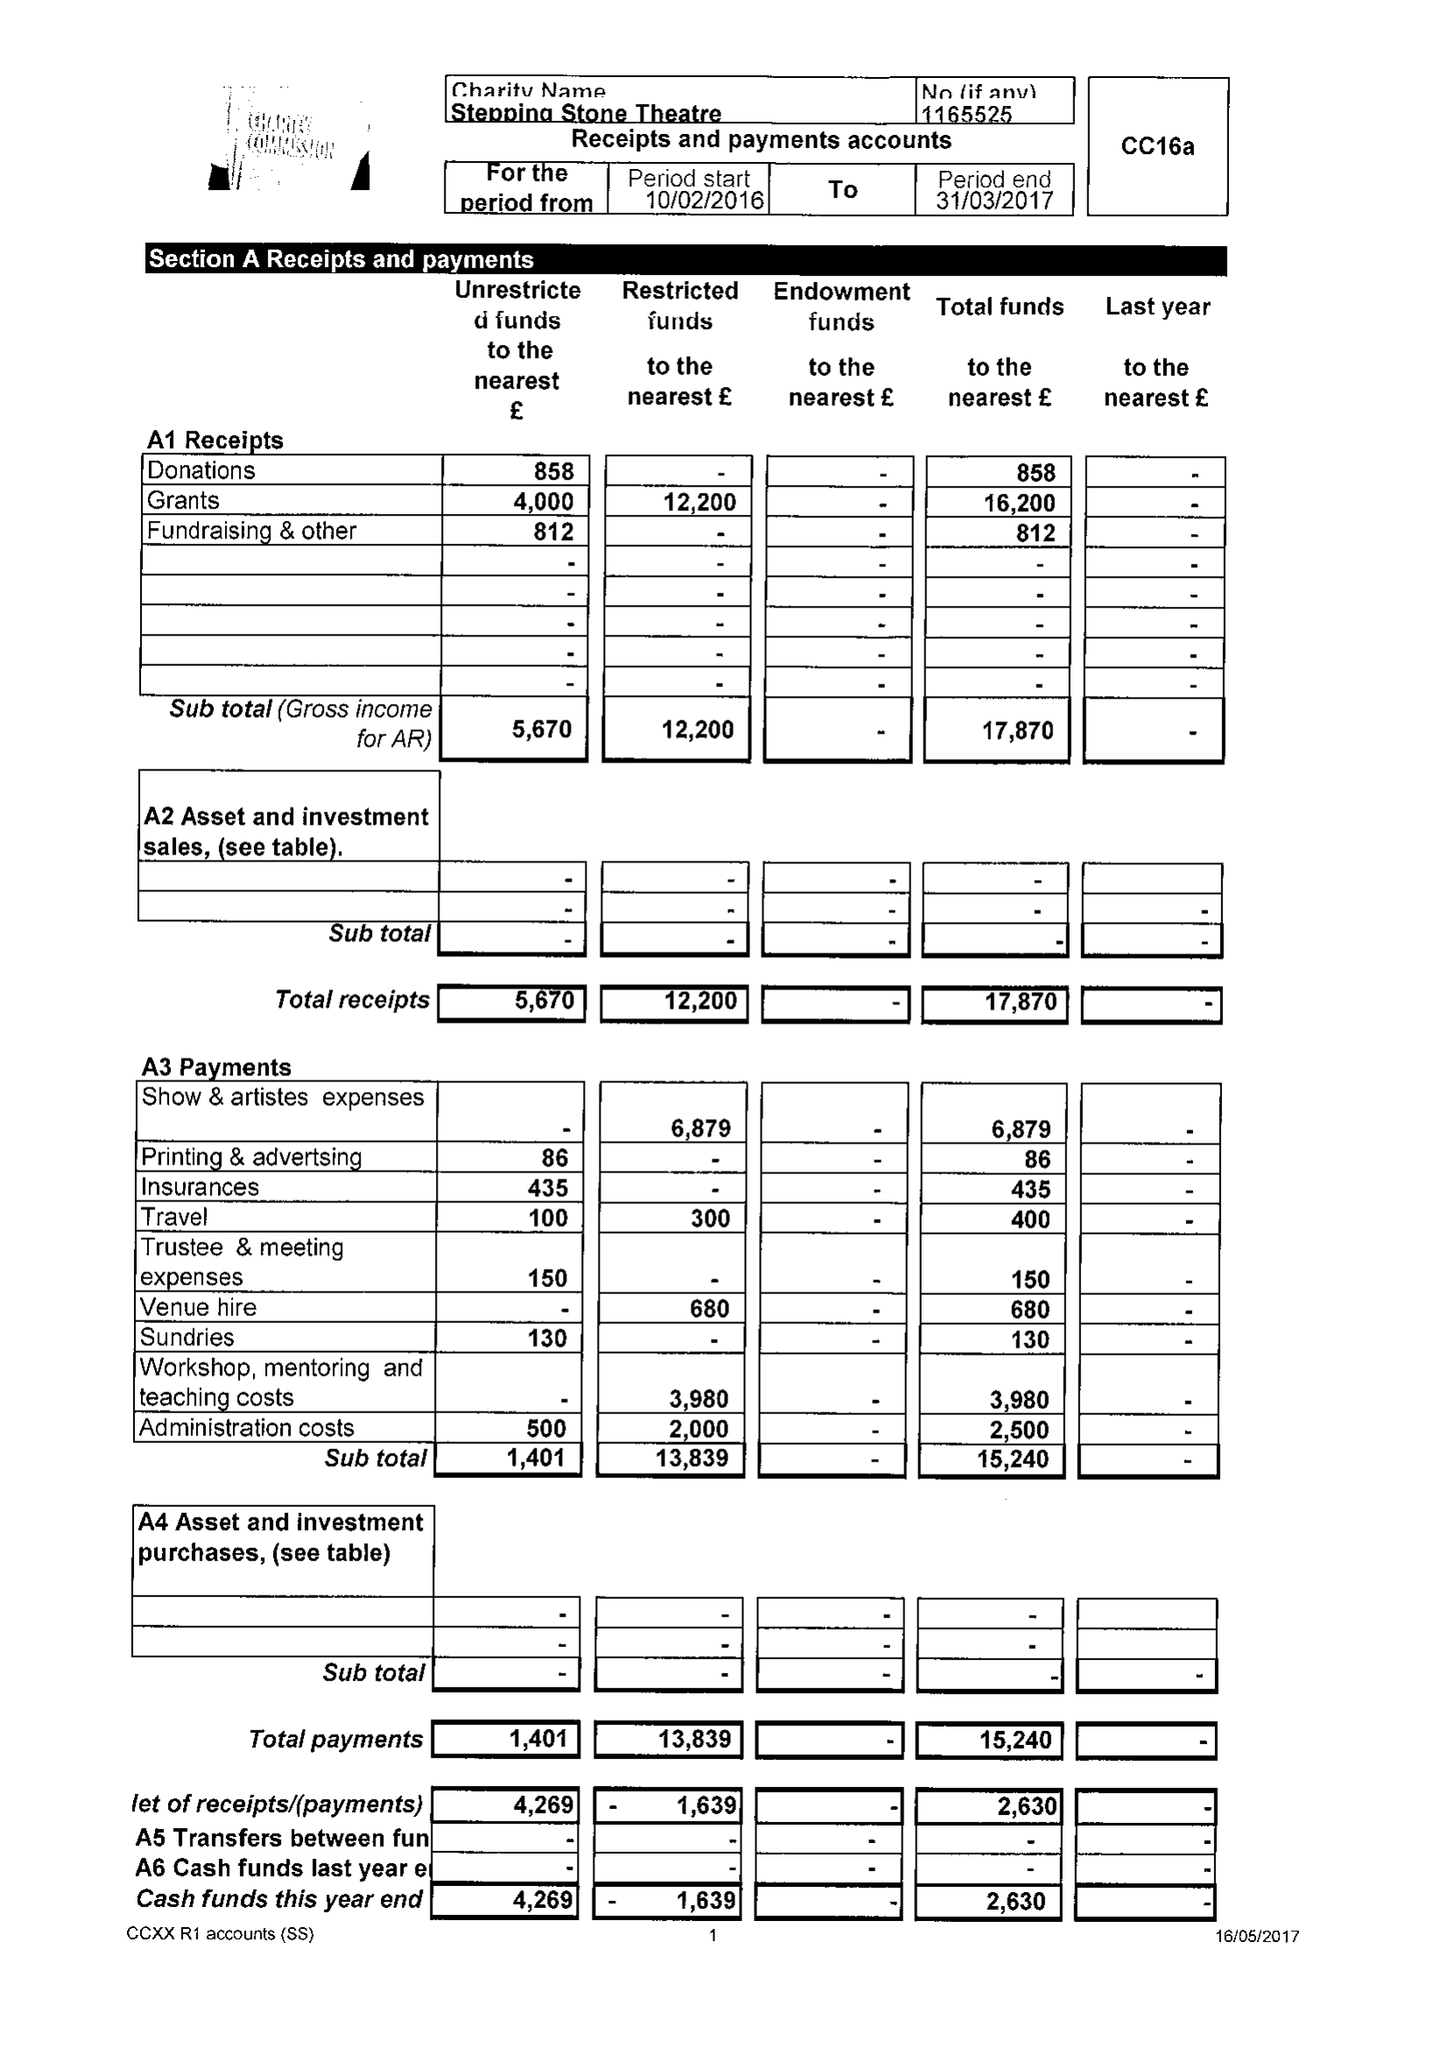What is the value for the charity_number?
Answer the question using a single word or phrase. 1165525 